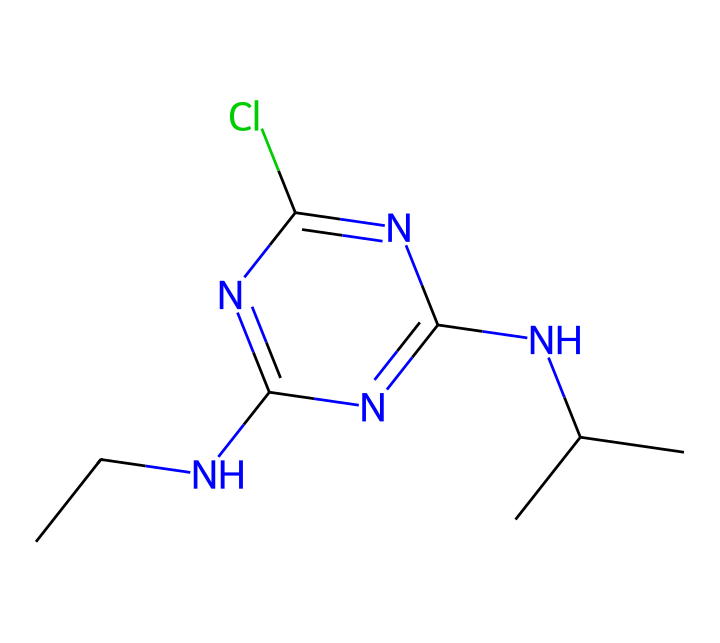What is the molecular formula of atrazine? The SMILES representation can be analyzed to determine the molecular formula by counting each type of atom represented in the structure. The SMILES shows that there are 10 carbon (C) atoms, 14 hydrogen (H) atoms, 3 nitrogen (N) atoms, and 1 chlorine (Cl) atom, leading to the formula C9H10ClN5.
Answer: C9H10ClN5 How many rings are present in atrazine's structure? By examining the chemical structure represented by the SMILES, one can see that there is a fused ring system. Specifically, there is a 5-membered ring that incorporates nitrogen atoms, along with an adjacent structure. This gives a total of one ring in the atrazine molecule.
Answer: 1 Which functional groups are present in atrazine? The chemical structure can be scanned for notable functional groups such as amine, aromatic, or halogen. In atrazine, the presence of the chloro group (Cl) indicates it is a haloalkane, and the two amine groups (NH) suggest it contains amine functionalities.
Answer: amine and haloalkane What is the principal use of atrazine? Understanding the context of atrazine's structure can help deduce its primary application. Atrazine is widely identified as a herbicide due to its chemical structure that allows it to inhibit photosynthesis in various weed species, making it effective in agriculture.
Answer: herbicide How many nitrogen atoms are in atrazine? A direct analysis of the chemical structure through the SMILES string shows that there are three nitrogen atoms (N) in the atrazine structure, identifiable in the sequence depicted in the SMILES representation.
Answer: 3 What element in the structure is responsible for the potential contamination of drinking water? The presence of chlorine (Cl), illustrated clearly in the chemical structure, is often associated with environmental contamination, especially concerning herbicides like atrazine, which can leach into water supplies.
Answer: chlorine 